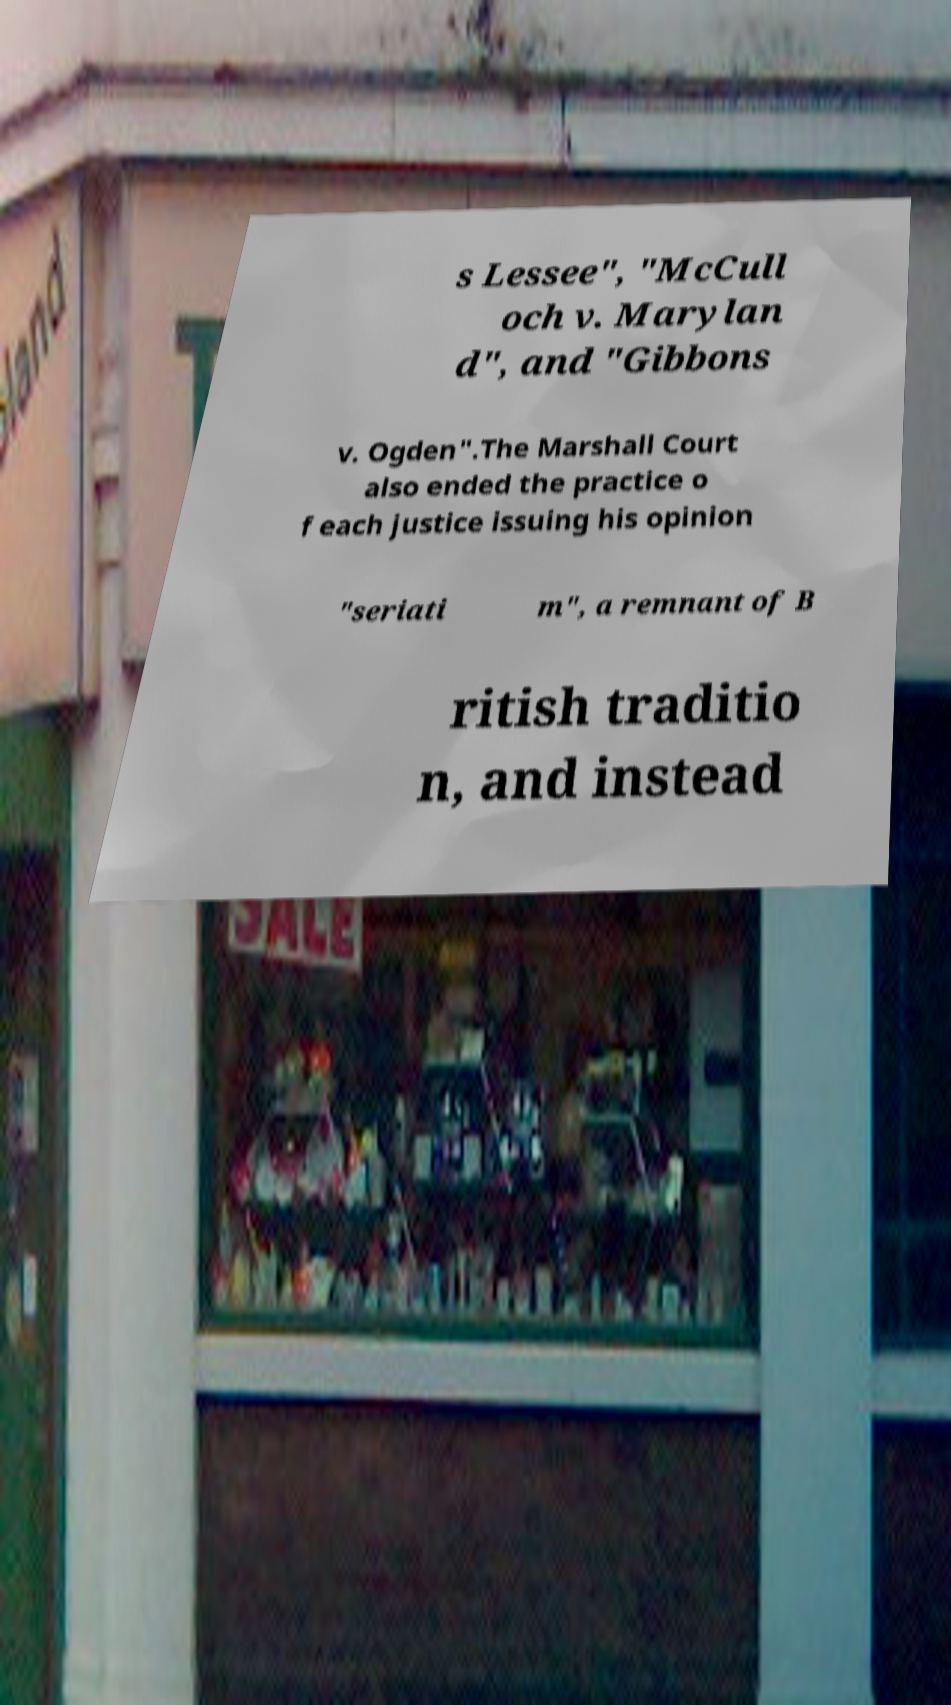I need the written content from this picture converted into text. Can you do that? s Lessee", "McCull och v. Marylan d", and "Gibbons v. Ogden".The Marshall Court also ended the practice o f each justice issuing his opinion "seriati m", a remnant of B ritish traditio n, and instead 